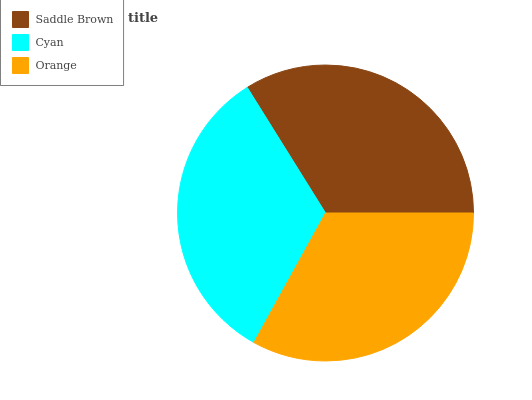Is Orange the minimum?
Answer yes or no. Yes. Is Saddle Brown the maximum?
Answer yes or no. Yes. Is Cyan the minimum?
Answer yes or no. No. Is Cyan the maximum?
Answer yes or no. No. Is Saddle Brown greater than Cyan?
Answer yes or no. Yes. Is Cyan less than Saddle Brown?
Answer yes or no. Yes. Is Cyan greater than Saddle Brown?
Answer yes or no. No. Is Saddle Brown less than Cyan?
Answer yes or no. No. Is Cyan the high median?
Answer yes or no. Yes. Is Cyan the low median?
Answer yes or no. Yes. Is Orange the high median?
Answer yes or no. No. Is Orange the low median?
Answer yes or no. No. 